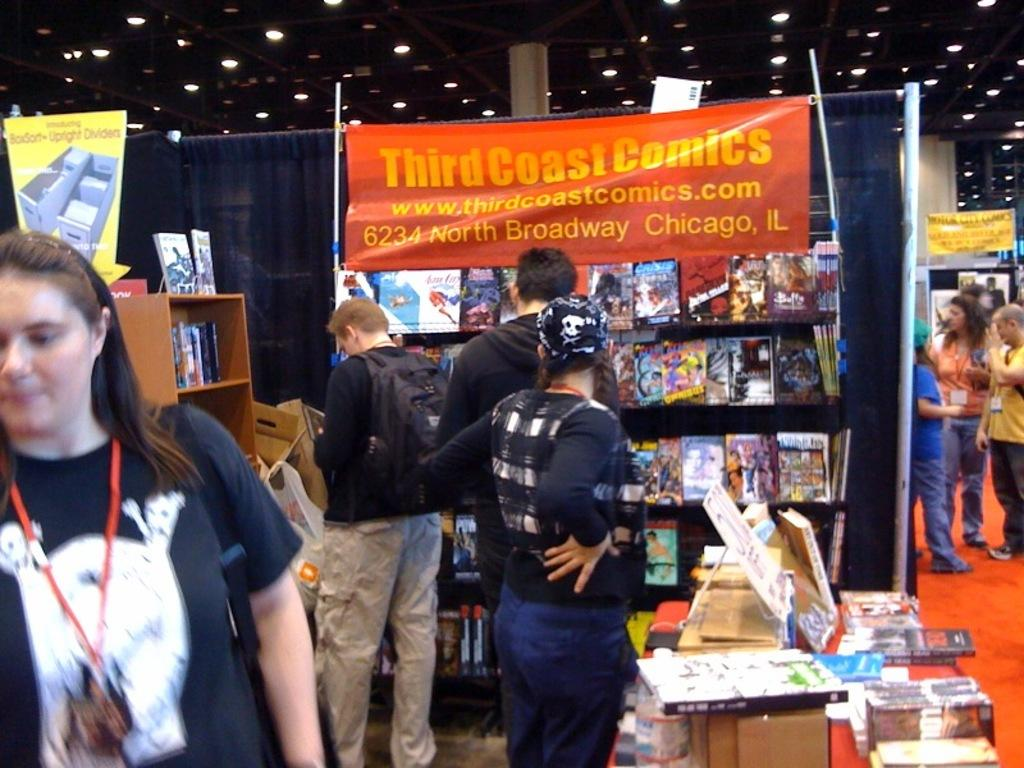<image>
Relay a brief, clear account of the picture shown. a stand saying Third Coast Comics at a convention hall 